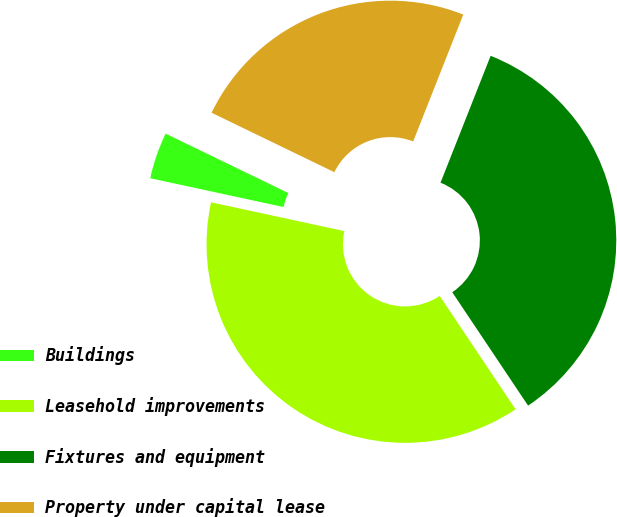<chart> <loc_0><loc_0><loc_500><loc_500><pie_chart><fcel>Buildings<fcel>Leasehold improvements<fcel>Fixtures and equipment<fcel>Property under capital lease<nl><fcel>3.79%<fcel>37.77%<fcel>34.63%<fcel>23.81%<nl></chart> 